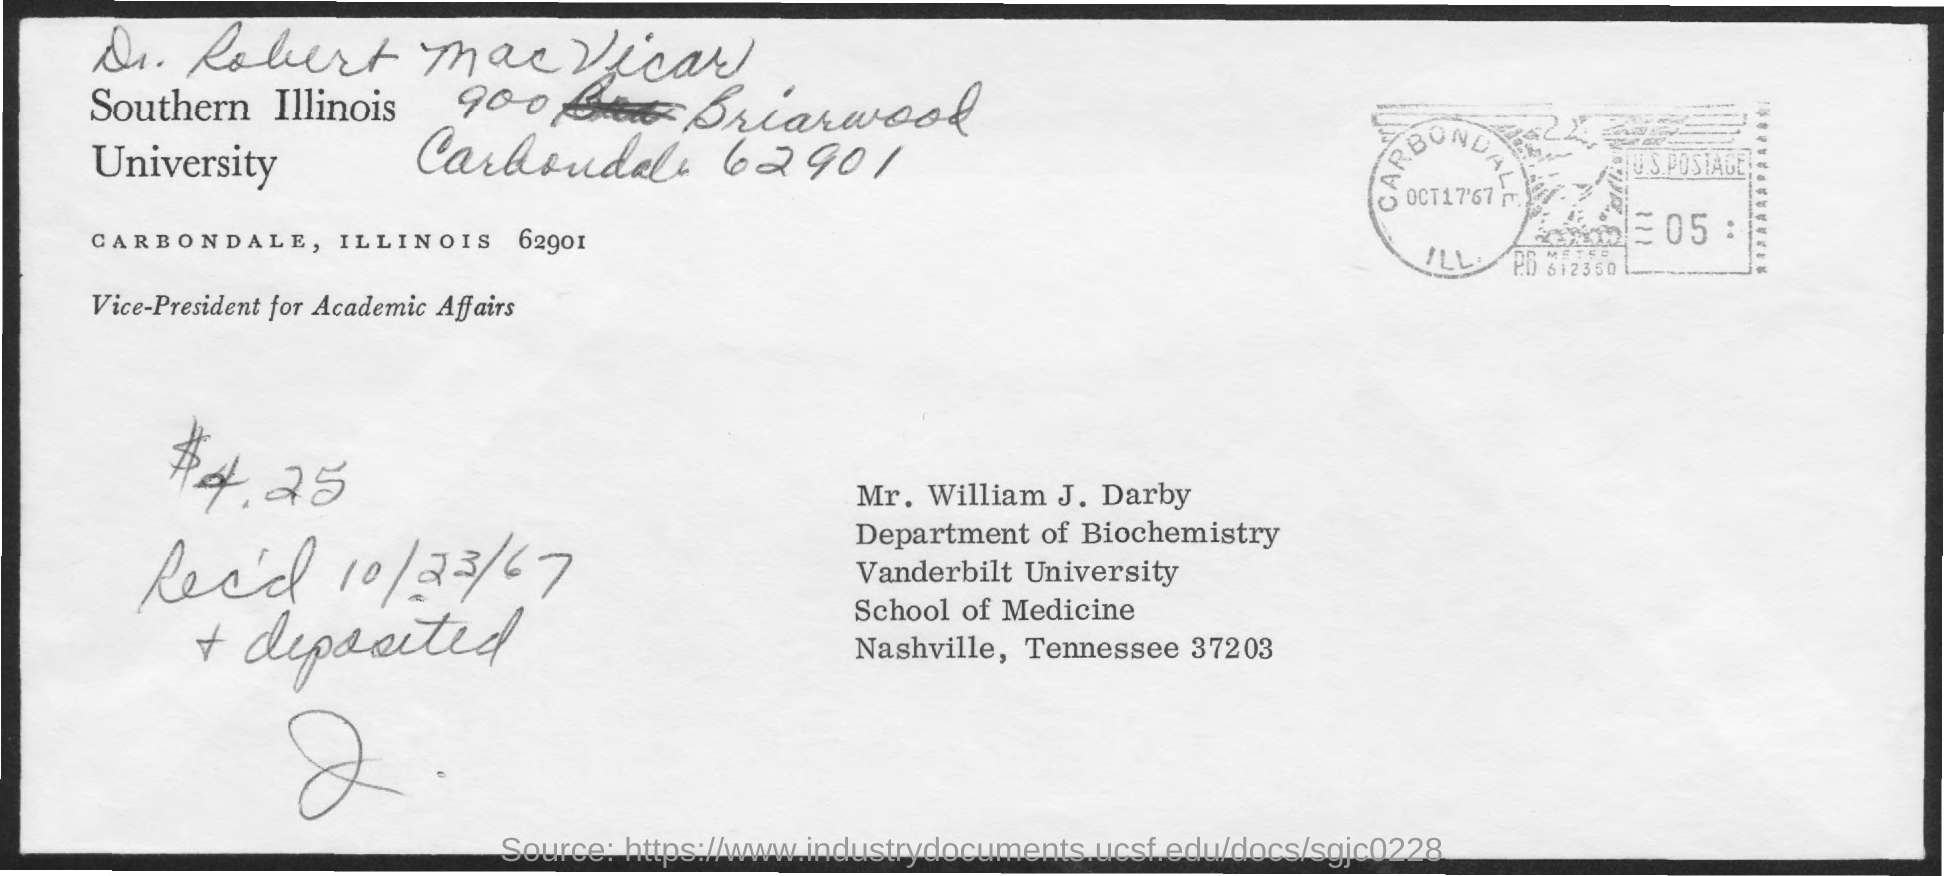Indicate a few pertinent items in this graphic. The postal card indicates that the received date is October 23, 1967. Mr. William J. Darby is from Vanderbilt University, as indicated in the address provided. 